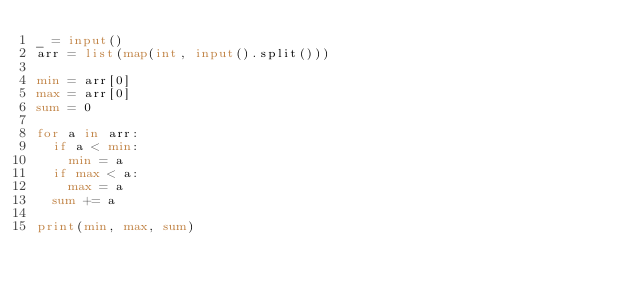Convert code to text. <code><loc_0><loc_0><loc_500><loc_500><_Python_>_ = input()
arr = list(map(int, input().split()))

min = arr[0]
max = arr[0]
sum = 0

for a in arr:
	if a < min:
		min = a
	if max < a:
		max = a
	sum += a

print(min, max, sum)</code> 